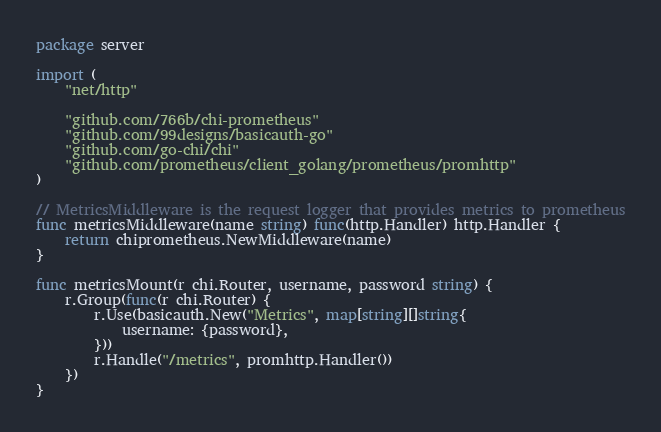Convert code to text. <code><loc_0><loc_0><loc_500><loc_500><_Go_>package server

import (
	"net/http"

	"github.com/766b/chi-prometheus"
	"github.com/99designs/basicauth-go"
	"github.com/go-chi/chi"
	"github.com/prometheus/client_golang/prometheus/promhttp"
)

// MetricsMiddleware is the request logger that provides metrics to prometheus
func metricsMiddleware(name string) func(http.Handler) http.Handler {
	return chiprometheus.NewMiddleware(name)
}

func metricsMount(r chi.Router, username, password string) {
	r.Group(func(r chi.Router) {
		r.Use(basicauth.New("Metrics", map[string][]string{
			username: {password},
		}))
		r.Handle("/metrics", promhttp.Handler())
	})
}
</code> 